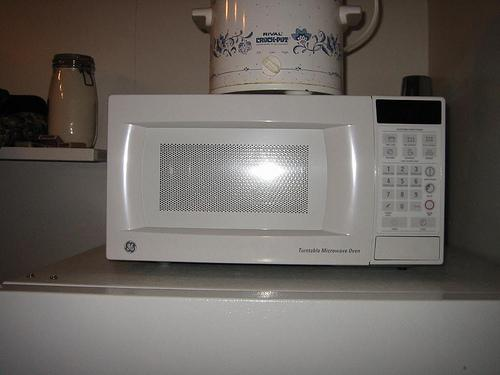Question: what color is the microwave?
Choices:
A. Black.
B. Silver.
C. Red.
D. White.
Answer with the letter. Answer: D Question: what is written on the slow cooker?
Choices:
A. Rival Crock Pot.
B. Mary's.
C. 400mL.
D. Stainless Steel.
Answer with the letter. Answer: A Question: where is the white porcelain container?
Choices:
A. In the cabinet.
B. On the table.
C. Aisle 6.
D. On the shelf.
Answer with the letter. Answer: D Question: what bran of microwave is pictured?
Choices:
A. Emerson.
B. Cuisinart.
C. GE.
D. Sunbeam.
Answer with the letter. Answer: C 